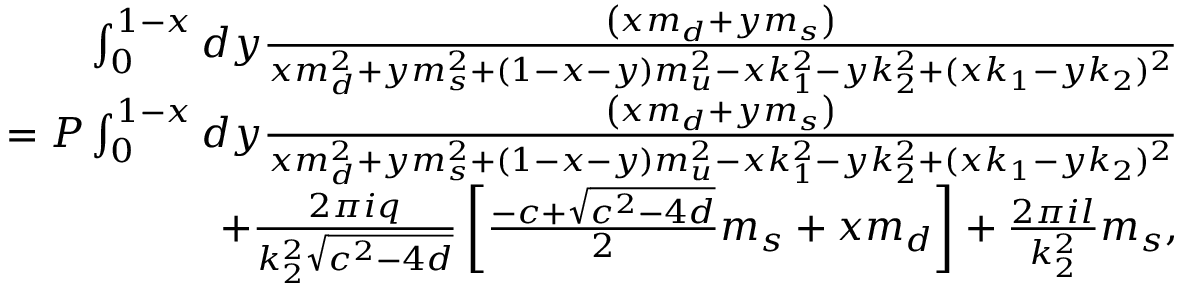<formula> <loc_0><loc_0><loc_500><loc_500>\begin{array} { r l r } & { \int _ { 0 } ^ { 1 - x } d y \frac { \left ( x m _ { d } + y m _ { s } \right ) } { x m _ { d } ^ { 2 } + y m _ { s } ^ { 2 } + ( 1 - x - y ) m _ { u } ^ { 2 } - x k _ { 1 } ^ { 2 } - y k _ { 2 } ^ { 2 } + ( x k _ { 1 } - y k _ { 2 } ) ^ { 2 } } } \\ & { = P \int _ { 0 } ^ { 1 - x } d y \frac { \left ( x m _ { d } + y m _ { s } \right ) } { x m _ { d } ^ { 2 } + y m _ { s } ^ { 2 } + ( 1 - x - y ) m _ { u } ^ { 2 } - x k _ { 1 } ^ { 2 } - y k _ { 2 } ^ { 2 } + ( x k _ { 1 } - y k _ { 2 } ) ^ { 2 } } } \\ & { + \frac { 2 \pi i q } { k _ { 2 } ^ { 2 } \sqrt { c ^ { 2 } - 4 d } } \left [ \frac { - c + \sqrt { c ^ { 2 } - 4 d } } { 2 } m _ { s } + x m _ { d } \right ] + \frac { 2 \pi i l } { k _ { 2 } ^ { 2 } } m _ { s } , } \end{array}</formula> 